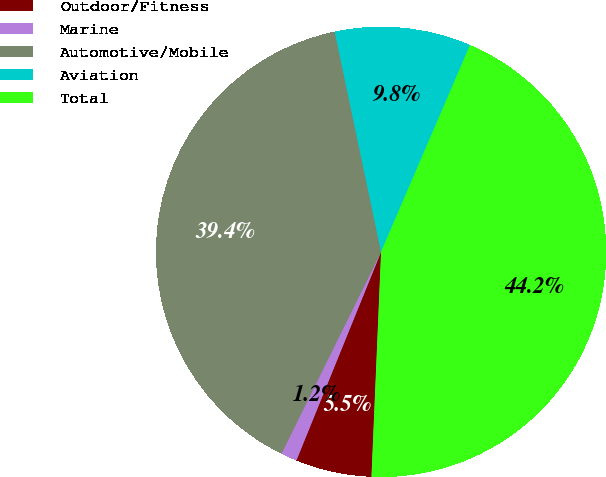<chart> <loc_0><loc_0><loc_500><loc_500><pie_chart><fcel>Outdoor/Fitness<fcel>Marine<fcel>Automotive/Mobile<fcel>Aviation<fcel>Total<nl><fcel>5.46%<fcel>1.16%<fcel>39.4%<fcel>9.77%<fcel>44.22%<nl></chart> 